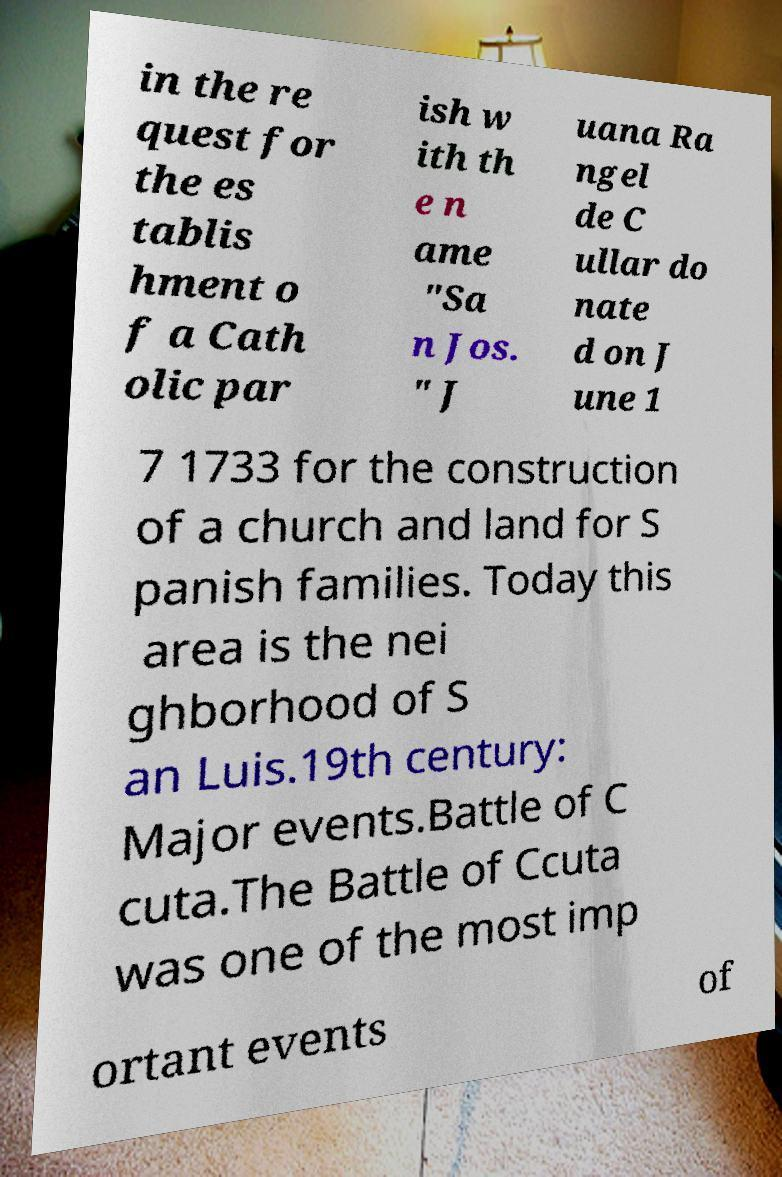Can you read and provide the text displayed in the image?This photo seems to have some interesting text. Can you extract and type it out for me? in the re quest for the es tablis hment o f a Cath olic par ish w ith th e n ame "Sa n Jos. " J uana Ra ngel de C ullar do nate d on J une 1 7 1733 for the construction of a church and land for S panish families. Today this area is the nei ghborhood of S an Luis.19th century: Major events.Battle of C cuta.The Battle of Ccuta was one of the most imp ortant events of 